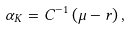Convert formula to latex. <formula><loc_0><loc_0><loc_500><loc_500>\alpha _ { K } = C ^ { - 1 } \left ( \mu - r \right ) ,</formula> 